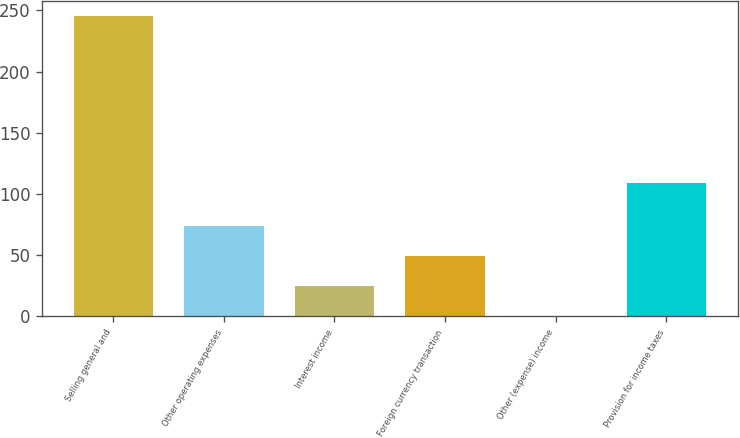<chart> <loc_0><loc_0><loc_500><loc_500><bar_chart><fcel>Selling general and<fcel>Other operating expenses<fcel>Interest income<fcel>Foreign currency transaction<fcel>Other (expense) income<fcel>Provision for income taxes<nl><fcel>245.6<fcel>73.96<fcel>24.92<fcel>49.44<fcel>0.4<fcel>109<nl></chart> 